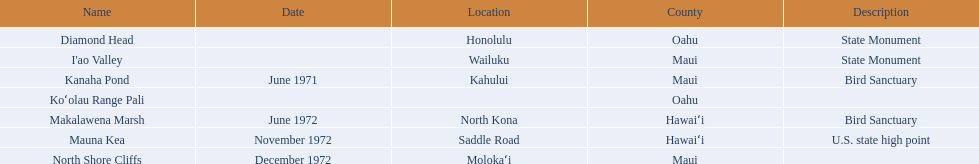What are the names of the different hawaiian national landmarks Diamond Head, I'ao Valley, Kanaha Pond, Koʻolau Range Pali, Makalawena Marsh, Mauna Kea, North Shore Cliffs. Which landmark does not have a location listed? Koʻolau Range Pali. 